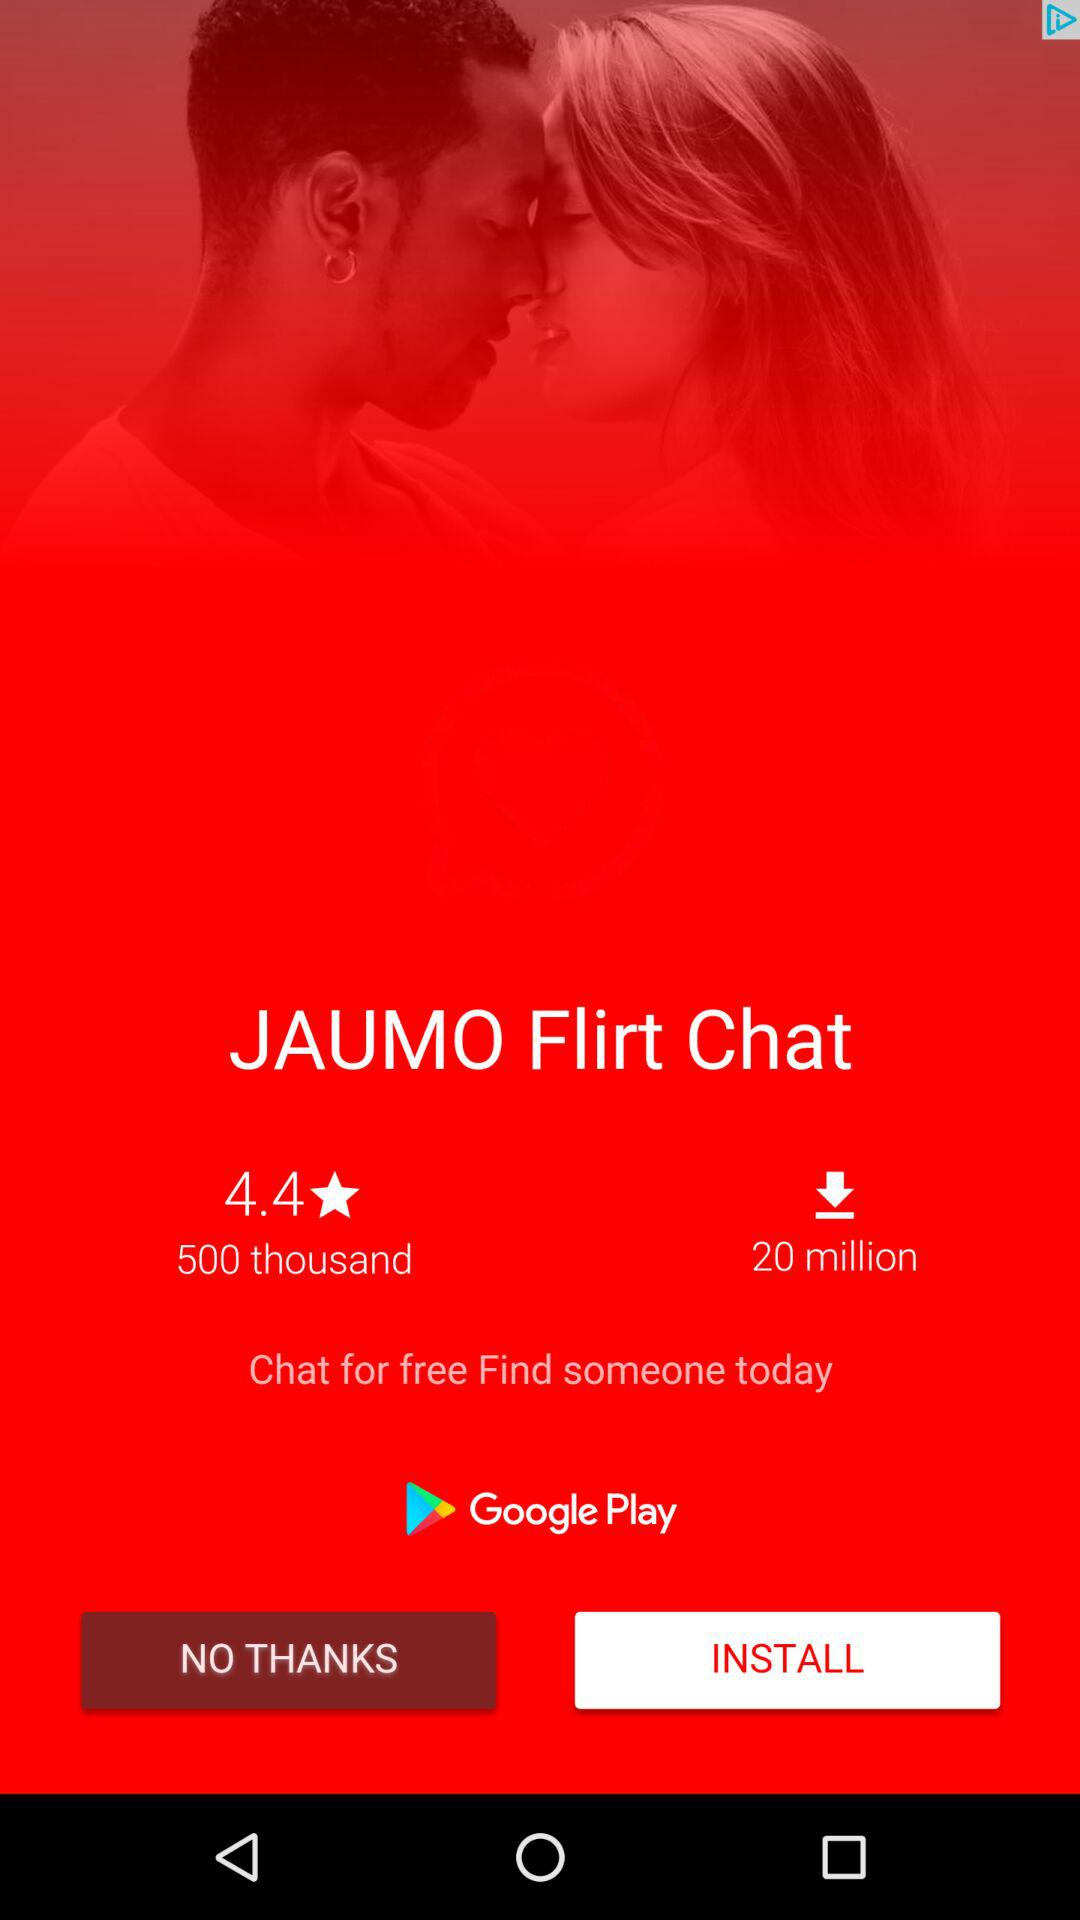What is the average rating of the app?
Answer the question using a single word or phrase. 4.4 